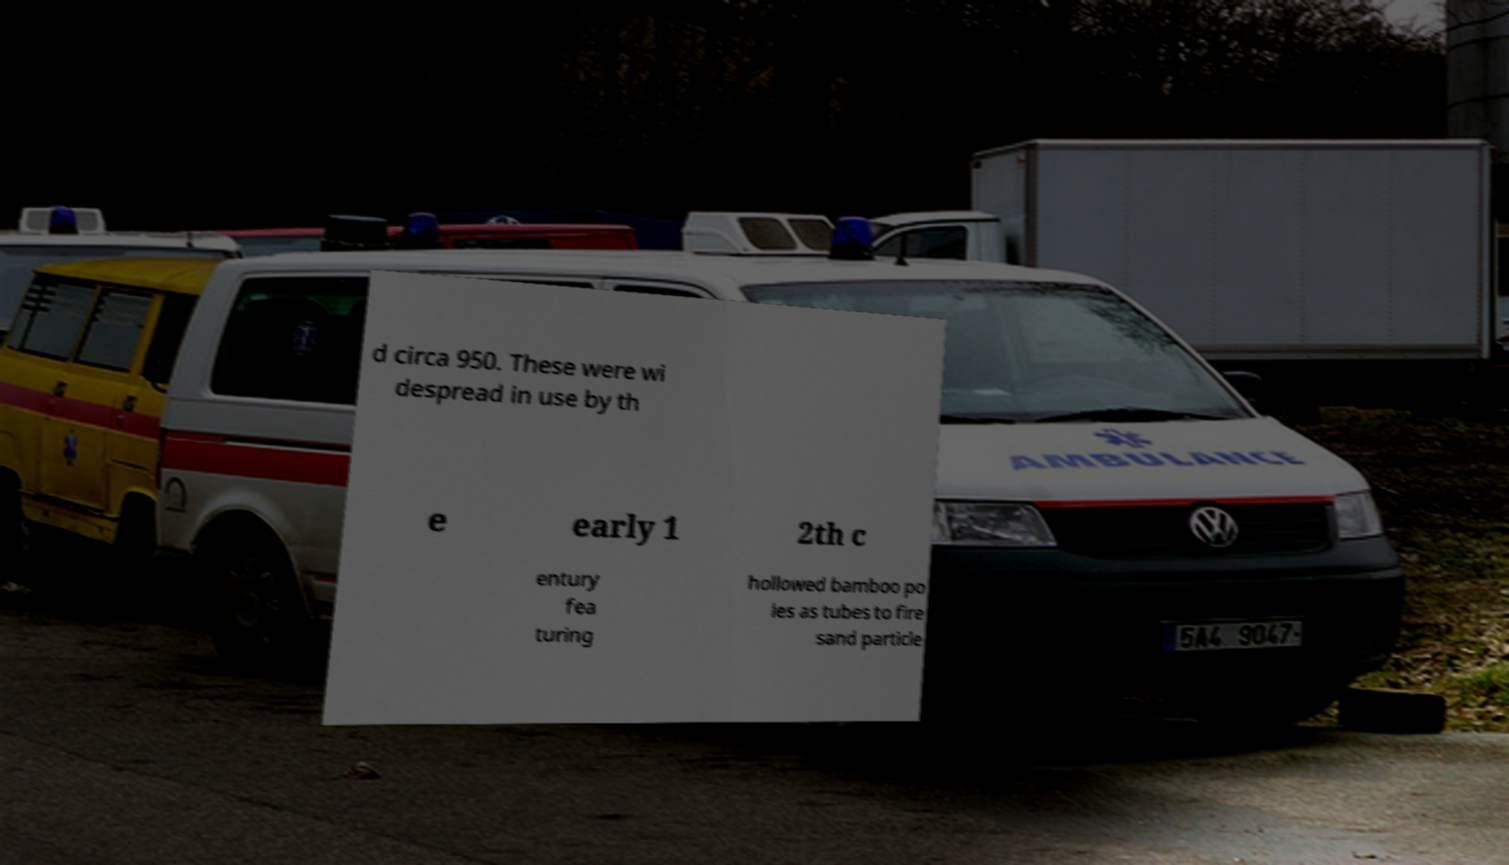Can you accurately transcribe the text from the provided image for me? d circa 950. These were wi despread in use by th e early 1 2th c entury fea turing hollowed bamboo po les as tubes to fire sand particle 